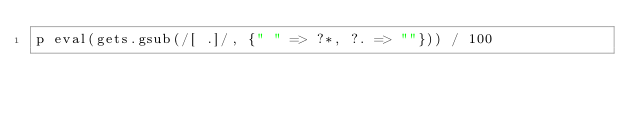Convert code to text. <code><loc_0><loc_0><loc_500><loc_500><_Ruby_>p eval(gets.gsub(/[ .]/, {" " => ?*, ?. => ""})) / 100</code> 